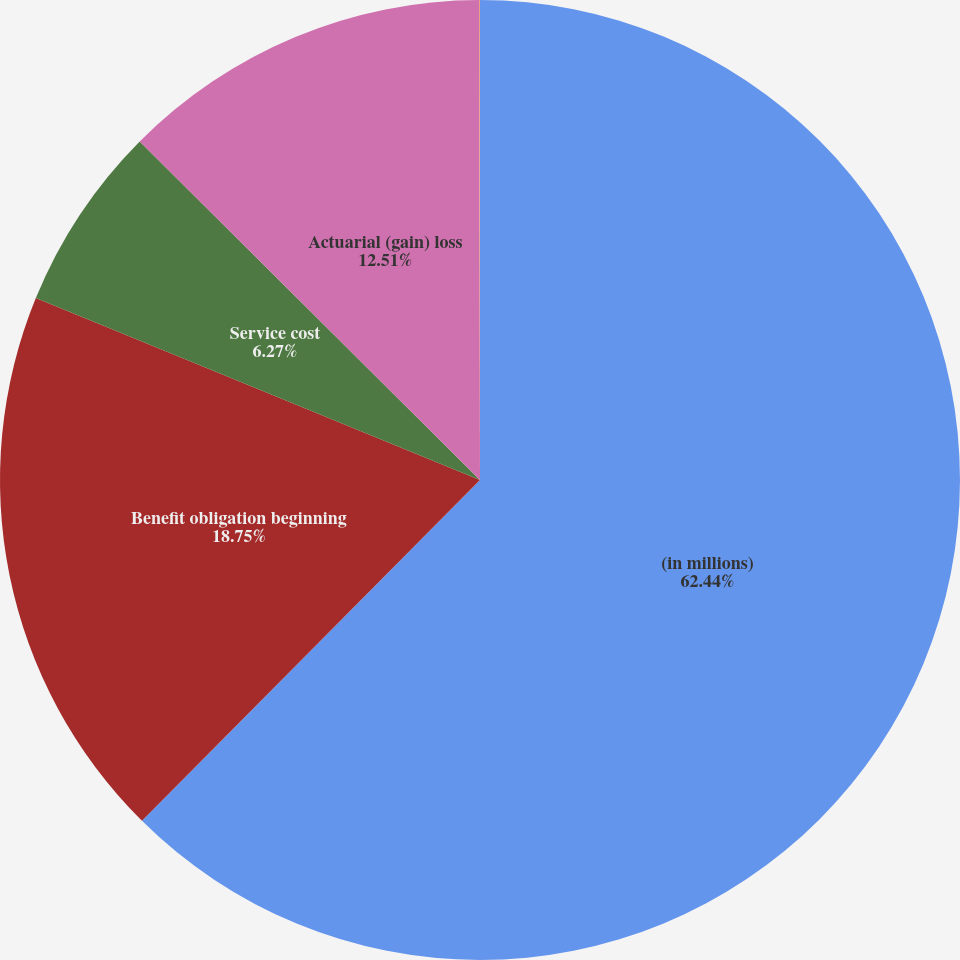Convert chart. <chart><loc_0><loc_0><loc_500><loc_500><pie_chart><fcel>(in millions)<fcel>Benefit obligation beginning<fcel>Service cost<fcel>Actuarial (gain) loss<fcel>AIG assets<nl><fcel>62.43%<fcel>18.75%<fcel>6.27%<fcel>12.51%<fcel>0.03%<nl></chart> 